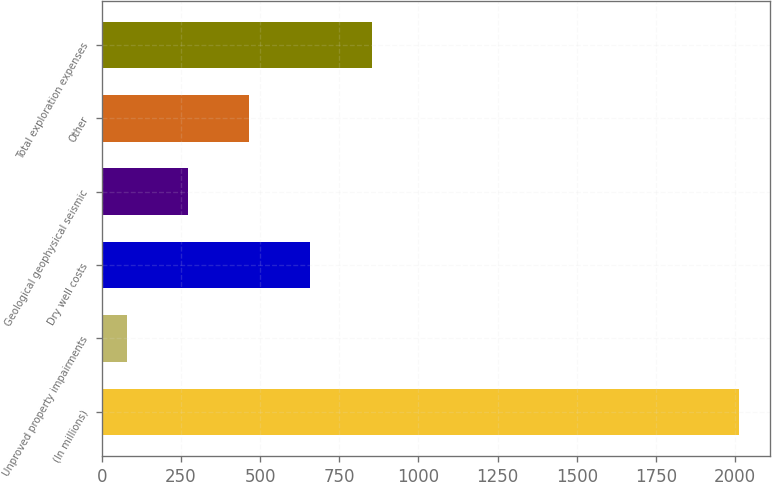<chart> <loc_0><loc_0><loc_500><loc_500><bar_chart><fcel>(In millions)<fcel>Unproved property impairments<fcel>Dry well costs<fcel>Geological geophysical seismic<fcel>Other<fcel>Total exploration expenses<nl><fcel>2011<fcel>79<fcel>658.6<fcel>272.2<fcel>465.4<fcel>851.8<nl></chart> 